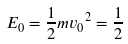Convert formula to latex. <formula><loc_0><loc_0><loc_500><loc_500>E _ { 0 } = \frac { 1 } { 2 } m { v _ { 0 } } ^ { 2 } = \frac { 1 } { 2 }</formula> 